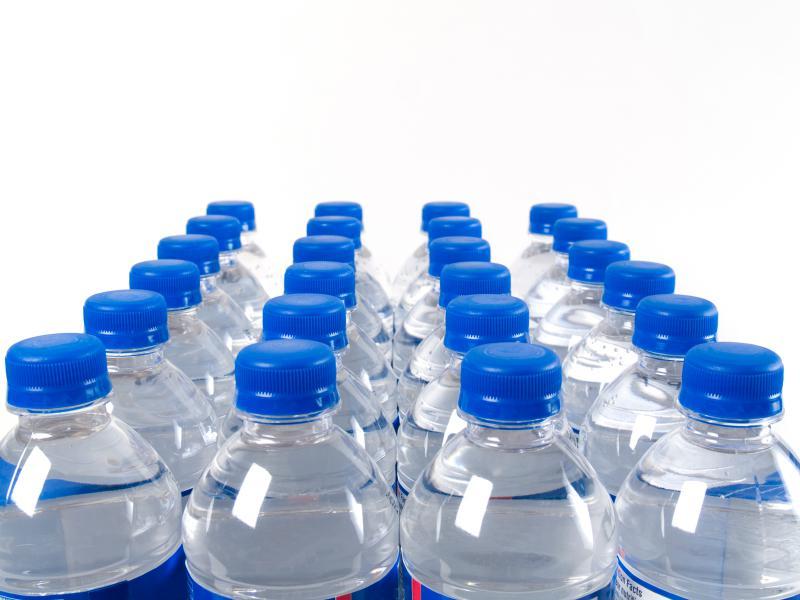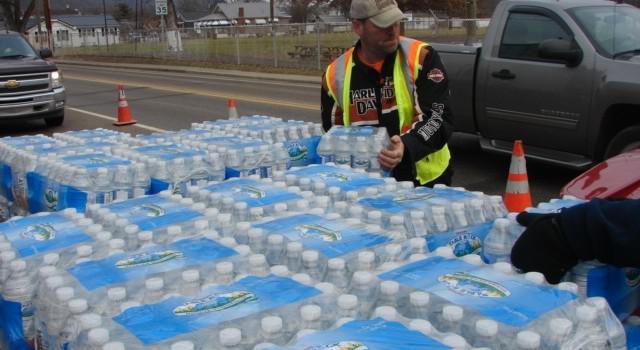The first image is the image on the left, the second image is the image on the right. Considering the images on both sides, is "There are at least two people in the image on the right." valid? Answer yes or no. No. 